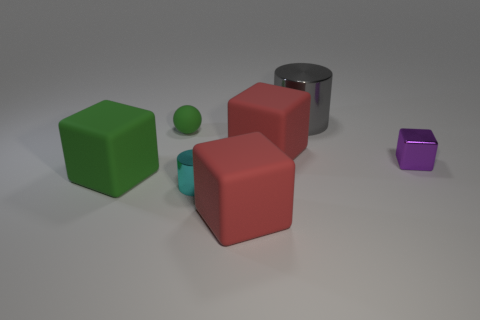The cylinder on the right side of the cylinder to the left of the metal cylinder that is behind the tiny green matte object is what color?
Offer a terse response. Gray. Is the number of cyan cylinders in front of the green ball greater than the number of small cylinders on the right side of the gray metal cylinder?
Offer a terse response. Yes. How many other things are the same size as the gray shiny thing?
Offer a very short reply. 3. There is a matte thing that is the same color as the tiny ball; what size is it?
Your answer should be very brief. Large. The big red object to the right of the red cube that is in front of the large green matte cube is made of what material?
Your answer should be very brief. Rubber. Are there any cyan cylinders behind the big green block?
Your answer should be very brief. No. Is the number of matte things right of the tiny ball greater than the number of big metal cylinders?
Make the answer very short. Yes. Are there any other things of the same color as the tiny rubber thing?
Your answer should be compact. Yes. What is the color of the matte thing that is the same size as the metallic cube?
Your answer should be compact. Green. Are there any blocks to the left of the large rubber object that is behind the purple block?
Offer a very short reply. Yes. 